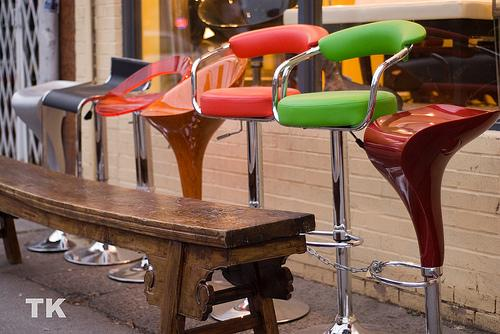What kind of wall is in the background and what is unique about it? The background features a white and beige brick wall; grime and dirt are visible at the bottom part of the bricks. Provide a brief overview of the main objects in the image. Several multicolored barstools with various shapes along with a wooden bench are placed on a sidewalk outside a store with a white bricked wall. In a short sentence, describe the most noticeable feature of the image. A variety of colorful and uniquely shaped barstools are displayed on the sidewalk outside a store. Highlight the most distinctive aspect of the various furniture pieces in the image. The barstools in the image stand out due to their diverse shapes, metal bases, and bright colors, such as red, green, and orange. Describe the furniture items displayed in the image and their arrangement. Seven differently shaped and colored barstools, along with a weathered wooden bench, are showcased on a sidewalk outside a store. State the main theme of the image and describe the setting. The main theme is an outdoor furniture display featuring barstools and a bench, set on a sidewalk by a store with a white brick wall. What kind of outdoor setting is shown in the image and what are the main objects? The image depicts a concrete sidewalk outside a store, displaying various multicolored barstools and a wooden bench. Identify the main pieces of furniture in the image and the surface they are on. The image features barstools and a wooden bench placed on a sidewalk with cracks and gravel. Mention the most common element in this image along with its colors. Barstools are the most common element, available in red, green, orange, and black colors with chrome details. What type of scene is depicted in this image and what is the most eye-catching detail? A furniture display on a sidewalk is shown, with the diverse colors and shapes of the barstools being the most eye-catching detail. 